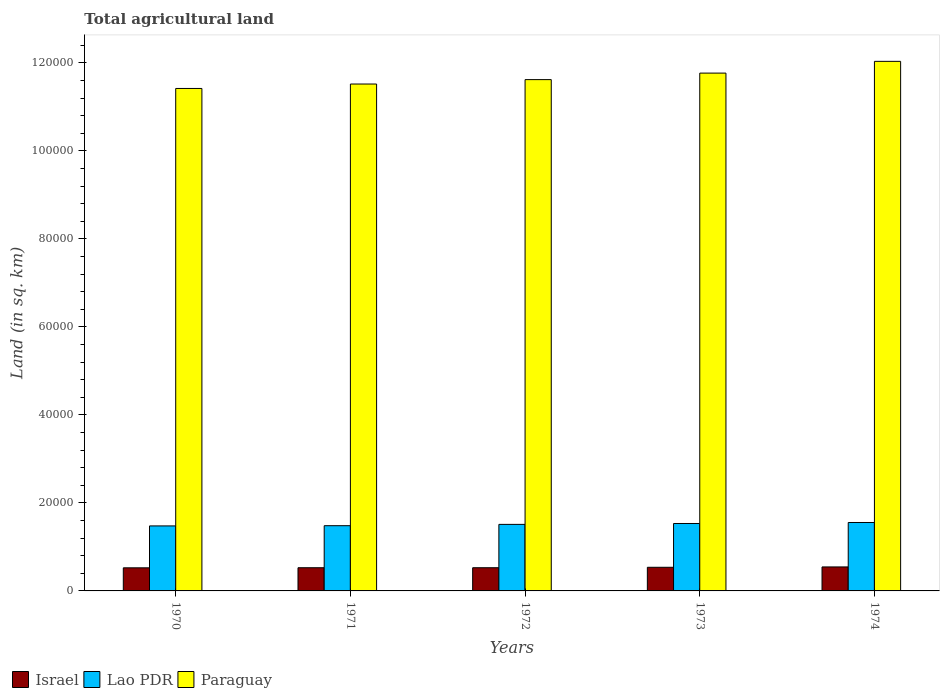Are the number of bars on each tick of the X-axis equal?
Make the answer very short. Yes. How many bars are there on the 2nd tick from the left?
Your answer should be compact. 3. What is the total agricultural land in Paraguay in 1970?
Keep it short and to the point. 1.14e+05. Across all years, what is the maximum total agricultural land in Lao PDR?
Give a very brief answer. 1.56e+04. Across all years, what is the minimum total agricultural land in Israel?
Give a very brief answer. 5250. In which year was the total agricultural land in Paraguay maximum?
Your response must be concise. 1974. In which year was the total agricultural land in Lao PDR minimum?
Offer a terse response. 1970. What is the total total agricultural land in Israel in the graph?
Provide a succinct answer. 2.66e+04. What is the difference between the total agricultural land in Paraguay in 1971 and that in 1974?
Keep it short and to the point. -5150. What is the difference between the total agricultural land in Israel in 1974 and the total agricultural land in Paraguay in 1972?
Provide a short and direct response. -1.11e+05. What is the average total agricultural land in Israel per year?
Ensure brevity in your answer.  5322. In the year 1972, what is the difference between the total agricultural land in Israel and total agricultural land in Lao PDR?
Provide a short and direct response. -9850. What is the ratio of the total agricultural land in Paraguay in 1970 to that in 1973?
Keep it short and to the point. 0.97. Is the total agricultural land in Israel in 1971 less than that in 1972?
Provide a short and direct response. No. What is the difference between the highest and the second highest total agricultural land in Israel?
Provide a short and direct response. 80. What is the difference between the highest and the lowest total agricultural land in Israel?
Make the answer very short. 200. What does the 3rd bar from the left in 1970 represents?
Offer a terse response. Paraguay. What does the 1st bar from the right in 1973 represents?
Give a very brief answer. Paraguay. How many bars are there?
Keep it short and to the point. 15. Are all the bars in the graph horizontal?
Give a very brief answer. No. What is the difference between two consecutive major ticks on the Y-axis?
Make the answer very short. 2.00e+04. What is the title of the graph?
Ensure brevity in your answer.  Total agricultural land. What is the label or title of the Y-axis?
Provide a short and direct response. Land (in sq. km). What is the Land (in sq. km) of Israel in 1970?
Your answer should be very brief. 5250. What is the Land (in sq. km) of Lao PDR in 1970?
Your response must be concise. 1.48e+04. What is the Land (in sq. km) in Paraguay in 1970?
Your answer should be very brief. 1.14e+05. What is the Land (in sq. km) in Israel in 1971?
Offer a terse response. 5270. What is the Land (in sq. km) of Lao PDR in 1971?
Make the answer very short. 1.48e+04. What is the Land (in sq. km) of Paraguay in 1971?
Provide a short and direct response. 1.15e+05. What is the Land (in sq. km) in Israel in 1972?
Make the answer very short. 5270. What is the Land (in sq. km) of Lao PDR in 1972?
Your answer should be compact. 1.51e+04. What is the Land (in sq. km) in Paraguay in 1972?
Keep it short and to the point. 1.16e+05. What is the Land (in sq. km) in Israel in 1973?
Your answer should be very brief. 5370. What is the Land (in sq. km) of Lao PDR in 1973?
Your answer should be compact. 1.53e+04. What is the Land (in sq. km) of Paraguay in 1973?
Ensure brevity in your answer.  1.18e+05. What is the Land (in sq. km) in Israel in 1974?
Your response must be concise. 5450. What is the Land (in sq. km) of Lao PDR in 1974?
Ensure brevity in your answer.  1.56e+04. What is the Land (in sq. km) in Paraguay in 1974?
Make the answer very short. 1.20e+05. Across all years, what is the maximum Land (in sq. km) in Israel?
Your answer should be very brief. 5450. Across all years, what is the maximum Land (in sq. km) of Lao PDR?
Offer a terse response. 1.56e+04. Across all years, what is the maximum Land (in sq. km) in Paraguay?
Offer a very short reply. 1.20e+05. Across all years, what is the minimum Land (in sq. km) of Israel?
Your answer should be very brief. 5250. Across all years, what is the minimum Land (in sq. km) in Lao PDR?
Your answer should be very brief. 1.48e+04. Across all years, what is the minimum Land (in sq. km) of Paraguay?
Provide a short and direct response. 1.14e+05. What is the total Land (in sq. km) in Israel in the graph?
Offer a very short reply. 2.66e+04. What is the total Land (in sq. km) in Lao PDR in the graph?
Provide a short and direct response. 7.56e+04. What is the total Land (in sq. km) in Paraguay in the graph?
Offer a terse response. 5.84e+05. What is the difference between the Land (in sq. km) in Israel in 1970 and that in 1971?
Keep it short and to the point. -20. What is the difference between the Land (in sq. km) of Lao PDR in 1970 and that in 1971?
Keep it short and to the point. -50. What is the difference between the Land (in sq. km) in Paraguay in 1970 and that in 1971?
Keep it short and to the point. -1010. What is the difference between the Land (in sq. km) of Lao PDR in 1970 and that in 1972?
Your response must be concise. -350. What is the difference between the Land (in sq. km) in Paraguay in 1970 and that in 1972?
Provide a succinct answer. -2010. What is the difference between the Land (in sq. km) of Israel in 1970 and that in 1973?
Your answer should be very brief. -120. What is the difference between the Land (in sq. km) in Lao PDR in 1970 and that in 1973?
Keep it short and to the point. -550. What is the difference between the Land (in sq. km) of Paraguay in 1970 and that in 1973?
Make the answer very short. -3490. What is the difference between the Land (in sq. km) in Israel in 1970 and that in 1974?
Ensure brevity in your answer.  -200. What is the difference between the Land (in sq. km) in Lao PDR in 1970 and that in 1974?
Your answer should be very brief. -780. What is the difference between the Land (in sq. km) in Paraguay in 1970 and that in 1974?
Offer a very short reply. -6160. What is the difference between the Land (in sq. km) in Israel in 1971 and that in 1972?
Your answer should be compact. 0. What is the difference between the Land (in sq. km) of Lao PDR in 1971 and that in 1972?
Provide a succinct answer. -300. What is the difference between the Land (in sq. km) in Paraguay in 1971 and that in 1972?
Offer a very short reply. -1000. What is the difference between the Land (in sq. km) in Israel in 1971 and that in 1973?
Your answer should be compact. -100. What is the difference between the Land (in sq. km) in Lao PDR in 1971 and that in 1973?
Provide a succinct answer. -500. What is the difference between the Land (in sq. km) in Paraguay in 1971 and that in 1973?
Provide a short and direct response. -2480. What is the difference between the Land (in sq. km) of Israel in 1971 and that in 1974?
Offer a very short reply. -180. What is the difference between the Land (in sq. km) of Lao PDR in 1971 and that in 1974?
Make the answer very short. -730. What is the difference between the Land (in sq. km) of Paraguay in 1971 and that in 1974?
Your answer should be very brief. -5150. What is the difference between the Land (in sq. km) in Israel in 1972 and that in 1973?
Offer a terse response. -100. What is the difference between the Land (in sq. km) of Lao PDR in 1972 and that in 1973?
Make the answer very short. -200. What is the difference between the Land (in sq. km) of Paraguay in 1972 and that in 1973?
Your answer should be very brief. -1480. What is the difference between the Land (in sq. km) of Israel in 1972 and that in 1974?
Provide a succinct answer. -180. What is the difference between the Land (in sq. km) in Lao PDR in 1972 and that in 1974?
Give a very brief answer. -430. What is the difference between the Land (in sq. km) in Paraguay in 1972 and that in 1974?
Your answer should be compact. -4150. What is the difference between the Land (in sq. km) in Israel in 1973 and that in 1974?
Ensure brevity in your answer.  -80. What is the difference between the Land (in sq. km) of Lao PDR in 1973 and that in 1974?
Your answer should be very brief. -230. What is the difference between the Land (in sq. km) of Paraguay in 1973 and that in 1974?
Make the answer very short. -2670. What is the difference between the Land (in sq. km) in Israel in 1970 and the Land (in sq. km) in Lao PDR in 1971?
Ensure brevity in your answer.  -9570. What is the difference between the Land (in sq. km) in Israel in 1970 and the Land (in sq. km) in Paraguay in 1971?
Provide a succinct answer. -1.10e+05. What is the difference between the Land (in sq. km) of Lao PDR in 1970 and the Land (in sq. km) of Paraguay in 1971?
Your answer should be very brief. -1.00e+05. What is the difference between the Land (in sq. km) in Israel in 1970 and the Land (in sq. km) in Lao PDR in 1972?
Make the answer very short. -9870. What is the difference between the Land (in sq. km) of Israel in 1970 and the Land (in sq. km) of Paraguay in 1972?
Keep it short and to the point. -1.11e+05. What is the difference between the Land (in sq. km) of Lao PDR in 1970 and the Land (in sq. km) of Paraguay in 1972?
Ensure brevity in your answer.  -1.01e+05. What is the difference between the Land (in sq. km) of Israel in 1970 and the Land (in sq. km) of Lao PDR in 1973?
Give a very brief answer. -1.01e+04. What is the difference between the Land (in sq. km) in Israel in 1970 and the Land (in sq. km) in Paraguay in 1973?
Ensure brevity in your answer.  -1.12e+05. What is the difference between the Land (in sq. km) in Lao PDR in 1970 and the Land (in sq. km) in Paraguay in 1973?
Provide a short and direct response. -1.03e+05. What is the difference between the Land (in sq. km) of Israel in 1970 and the Land (in sq. km) of Lao PDR in 1974?
Offer a very short reply. -1.03e+04. What is the difference between the Land (in sq. km) of Israel in 1970 and the Land (in sq. km) of Paraguay in 1974?
Your response must be concise. -1.15e+05. What is the difference between the Land (in sq. km) of Lao PDR in 1970 and the Land (in sq. km) of Paraguay in 1974?
Provide a succinct answer. -1.06e+05. What is the difference between the Land (in sq. km) of Israel in 1971 and the Land (in sq. km) of Lao PDR in 1972?
Your answer should be very brief. -9850. What is the difference between the Land (in sq. km) of Israel in 1971 and the Land (in sq. km) of Paraguay in 1972?
Your answer should be compact. -1.11e+05. What is the difference between the Land (in sq. km) in Lao PDR in 1971 and the Land (in sq. km) in Paraguay in 1972?
Make the answer very short. -1.01e+05. What is the difference between the Land (in sq. km) of Israel in 1971 and the Land (in sq. km) of Lao PDR in 1973?
Offer a very short reply. -1.00e+04. What is the difference between the Land (in sq. km) of Israel in 1971 and the Land (in sq. km) of Paraguay in 1973?
Provide a short and direct response. -1.12e+05. What is the difference between the Land (in sq. km) in Lao PDR in 1971 and the Land (in sq. km) in Paraguay in 1973?
Ensure brevity in your answer.  -1.03e+05. What is the difference between the Land (in sq. km) in Israel in 1971 and the Land (in sq. km) in Lao PDR in 1974?
Provide a short and direct response. -1.03e+04. What is the difference between the Land (in sq. km) of Israel in 1971 and the Land (in sq. km) of Paraguay in 1974?
Make the answer very short. -1.15e+05. What is the difference between the Land (in sq. km) in Lao PDR in 1971 and the Land (in sq. km) in Paraguay in 1974?
Your response must be concise. -1.06e+05. What is the difference between the Land (in sq. km) of Israel in 1972 and the Land (in sq. km) of Lao PDR in 1973?
Offer a terse response. -1.00e+04. What is the difference between the Land (in sq. km) in Israel in 1972 and the Land (in sq. km) in Paraguay in 1973?
Make the answer very short. -1.12e+05. What is the difference between the Land (in sq. km) of Lao PDR in 1972 and the Land (in sq. km) of Paraguay in 1973?
Give a very brief answer. -1.03e+05. What is the difference between the Land (in sq. km) of Israel in 1972 and the Land (in sq. km) of Lao PDR in 1974?
Offer a terse response. -1.03e+04. What is the difference between the Land (in sq. km) of Israel in 1972 and the Land (in sq. km) of Paraguay in 1974?
Provide a succinct answer. -1.15e+05. What is the difference between the Land (in sq. km) in Lao PDR in 1972 and the Land (in sq. km) in Paraguay in 1974?
Your answer should be compact. -1.05e+05. What is the difference between the Land (in sq. km) in Israel in 1973 and the Land (in sq. km) in Lao PDR in 1974?
Provide a succinct answer. -1.02e+04. What is the difference between the Land (in sq. km) in Israel in 1973 and the Land (in sq. km) in Paraguay in 1974?
Keep it short and to the point. -1.15e+05. What is the difference between the Land (in sq. km) of Lao PDR in 1973 and the Land (in sq. km) of Paraguay in 1974?
Keep it short and to the point. -1.05e+05. What is the average Land (in sq. km) in Israel per year?
Give a very brief answer. 5322. What is the average Land (in sq. km) in Lao PDR per year?
Provide a succinct answer. 1.51e+04. What is the average Land (in sq. km) of Paraguay per year?
Your answer should be very brief. 1.17e+05. In the year 1970, what is the difference between the Land (in sq. km) in Israel and Land (in sq. km) in Lao PDR?
Offer a terse response. -9520. In the year 1970, what is the difference between the Land (in sq. km) in Israel and Land (in sq. km) in Paraguay?
Offer a very short reply. -1.09e+05. In the year 1970, what is the difference between the Land (in sq. km) in Lao PDR and Land (in sq. km) in Paraguay?
Your answer should be very brief. -9.94e+04. In the year 1971, what is the difference between the Land (in sq. km) in Israel and Land (in sq. km) in Lao PDR?
Provide a short and direct response. -9550. In the year 1971, what is the difference between the Land (in sq. km) in Israel and Land (in sq. km) in Paraguay?
Your response must be concise. -1.10e+05. In the year 1971, what is the difference between the Land (in sq. km) in Lao PDR and Land (in sq. km) in Paraguay?
Offer a very short reply. -1.00e+05. In the year 1972, what is the difference between the Land (in sq. km) in Israel and Land (in sq. km) in Lao PDR?
Your answer should be compact. -9850. In the year 1972, what is the difference between the Land (in sq. km) in Israel and Land (in sq. km) in Paraguay?
Your answer should be very brief. -1.11e+05. In the year 1972, what is the difference between the Land (in sq. km) in Lao PDR and Land (in sq. km) in Paraguay?
Your response must be concise. -1.01e+05. In the year 1973, what is the difference between the Land (in sq. km) of Israel and Land (in sq. km) of Lao PDR?
Your response must be concise. -9950. In the year 1973, what is the difference between the Land (in sq. km) in Israel and Land (in sq. km) in Paraguay?
Give a very brief answer. -1.12e+05. In the year 1973, what is the difference between the Land (in sq. km) of Lao PDR and Land (in sq. km) of Paraguay?
Your response must be concise. -1.02e+05. In the year 1974, what is the difference between the Land (in sq. km) of Israel and Land (in sq. km) of Lao PDR?
Give a very brief answer. -1.01e+04. In the year 1974, what is the difference between the Land (in sq. km) in Israel and Land (in sq. km) in Paraguay?
Your answer should be very brief. -1.15e+05. In the year 1974, what is the difference between the Land (in sq. km) of Lao PDR and Land (in sq. km) of Paraguay?
Ensure brevity in your answer.  -1.05e+05. What is the ratio of the Land (in sq. km) of Israel in 1970 to that in 1971?
Your response must be concise. 1. What is the ratio of the Land (in sq. km) in Lao PDR in 1970 to that in 1971?
Provide a short and direct response. 1. What is the ratio of the Land (in sq. km) of Lao PDR in 1970 to that in 1972?
Your response must be concise. 0.98. What is the ratio of the Land (in sq. km) of Paraguay in 1970 to that in 1972?
Provide a short and direct response. 0.98. What is the ratio of the Land (in sq. km) of Israel in 1970 to that in 1973?
Provide a succinct answer. 0.98. What is the ratio of the Land (in sq. km) in Lao PDR in 1970 to that in 1973?
Your answer should be compact. 0.96. What is the ratio of the Land (in sq. km) of Paraguay in 1970 to that in 1973?
Offer a terse response. 0.97. What is the ratio of the Land (in sq. km) in Israel in 1970 to that in 1974?
Offer a terse response. 0.96. What is the ratio of the Land (in sq. km) of Lao PDR in 1970 to that in 1974?
Provide a succinct answer. 0.95. What is the ratio of the Land (in sq. km) in Paraguay in 1970 to that in 1974?
Keep it short and to the point. 0.95. What is the ratio of the Land (in sq. km) of Israel in 1971 to that in 1972?
Provide a succinct answer. 1. What is the ratio of the Land (in sq. km) in Lao PDR in 1971 to that in 1972?
Your answer should be very brief. 0.98. What is the ratio of the Land (in sq. km) of Paraguay in 1971 to that in 1972?
Offer a very short reply. 0.99. What is the ratio of the Land (in sq. km) in Israel in 1971 to that in 1973?
Offer a very short reply. 0.98. What is the ratio of the Land (in sq. km) of Lao PDR in 1971 to that in 1973?
Keep it short and to the point. 0.97. What is the ratio of the Land (in sq. km) of Paraguay in 1971 to that in 1973?
Ensure brevity in your answer.  0.98. What is the ratio of the Land (in sq. km) of Lao PDR in 1971 to that in 1974?
Your response must be concise. 0.95. What is the ratio of the Land (in sq. km) in Paraguay in 1971 to that in 1974?
Offer a very short reply. 0.96. What is the ratio of the Land (in sq. km) in Israel in 1972 to that in 1973?
Offer a terse response. 0.98. What is the ratio of the Land (in sq. km) in Lao PDR in 1972 to that in 1973?
Your answer should be compact. 0.99. What is the ratio of the Land (in sq. km) in Paraguay in 1972 to that in 1973?
Provide a succinct answer. 0.99. What is the ratio of the Land (in sq. km) in Lao PDR in 1972 to that in 1974?
Your response must be concise. 0.97. What is the ratio of the Land (in sq. km) of Paraguay in 1972 to that in 1974?
Offer a terse response. 0.97. What is the ratio of the Land (in sq. km) of Lao PDR in 1973 to that in 1974?
Your response must be concise. 0.99. What is the ratio of the Land (in sq. km) of Paraguay in 1973 to that in 1974?
Provide a short and direct response. 0.98. What is the difference between the highest and the second highest Land (in sq. km) in Lao PDR?
Keep it short and to the point. 230. What is the difference between the highest and the second highest Land (in sq. km) in Paraguay?
Offer a very short reply. 2670. What is the difference between the highest and the lowest Land (in sq. km) in Israel?
Make the answer very short. 200. What is the difference between the highest and the lowest Land (in sq. km) in Lao PDR?
Ensure brevity in your answer.  780. What is the difference between the highest and the lowest Land (in sq. km) in Paraguay?
Your response must be concise. 6160. 